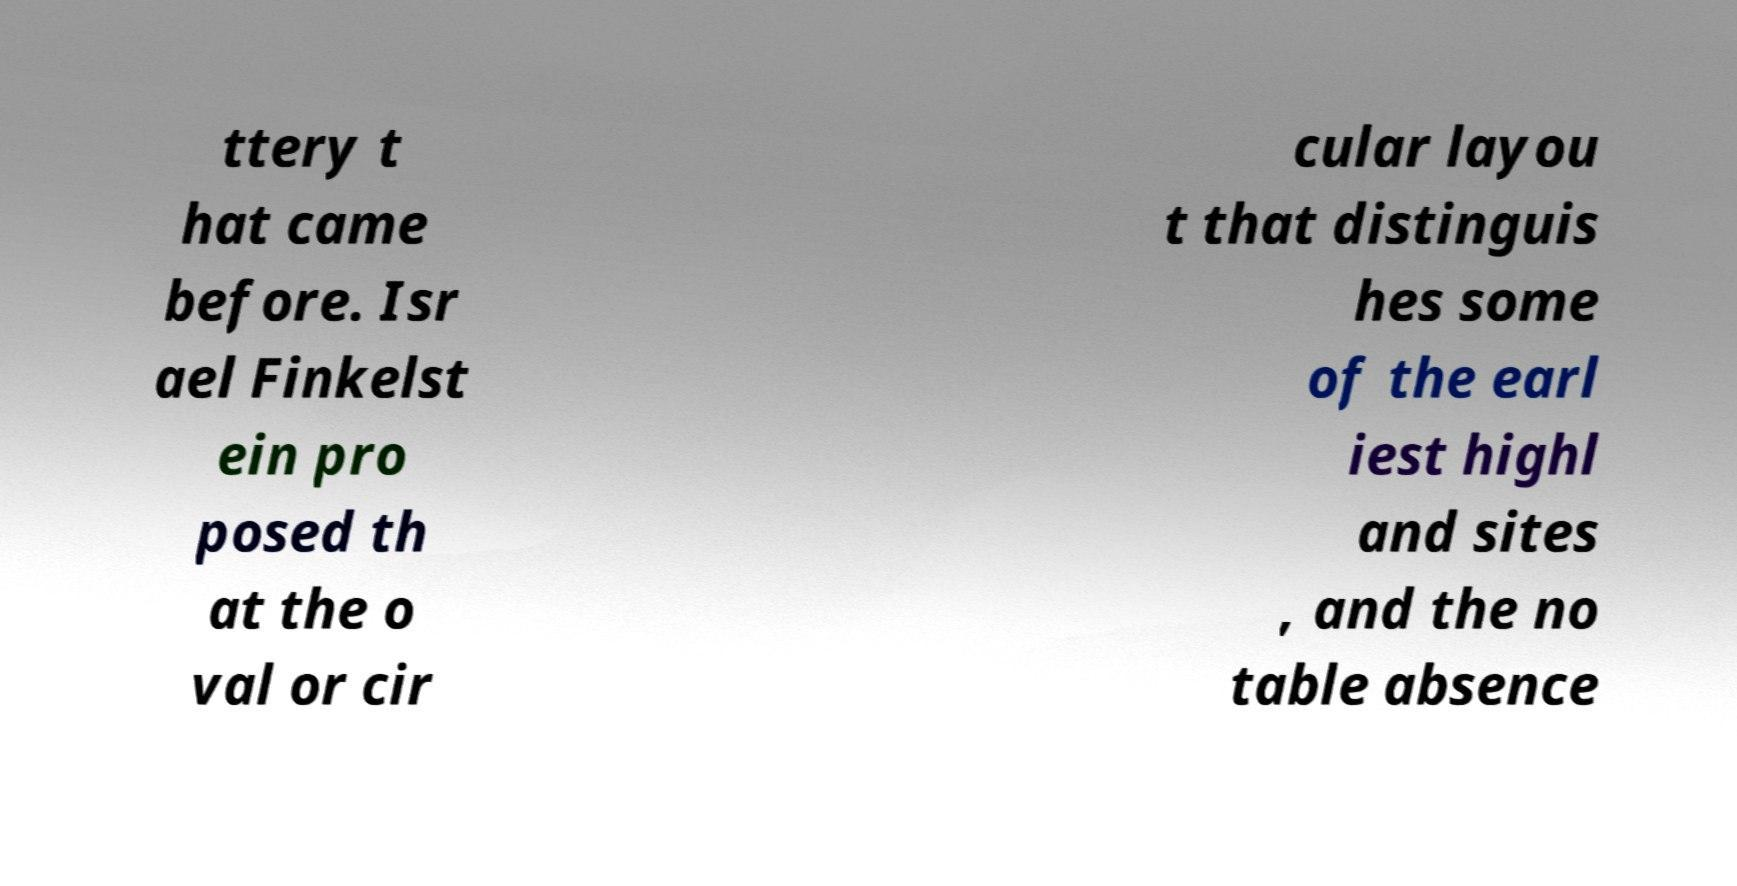Please read and relay the text visible in this image. What does it say? ttery t hat came before. Isr ael Finkelst ein pro posed th at the o val or cir cular layou t that distinguis hes some of the earl iest highl and sites , and the no table absence 